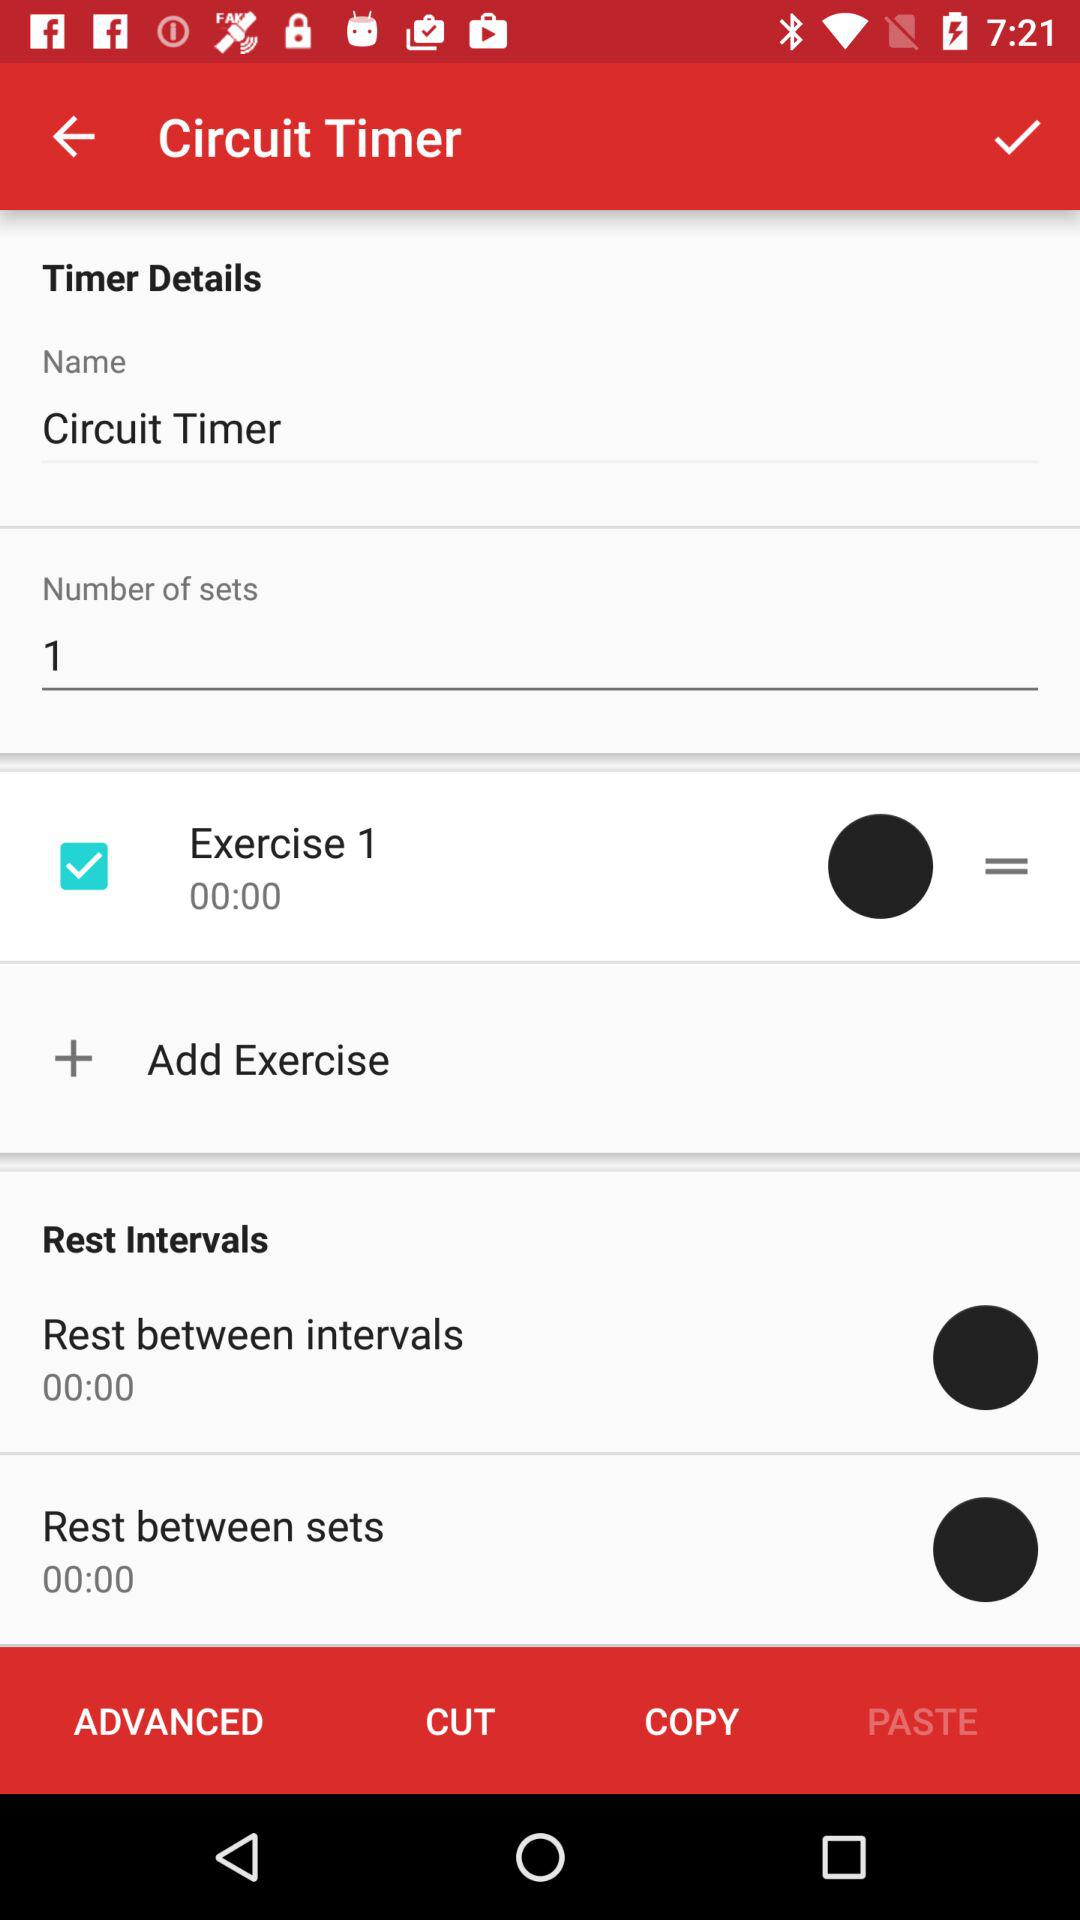How many exercises are there?
Answer the question using a single word or phrase. 1 